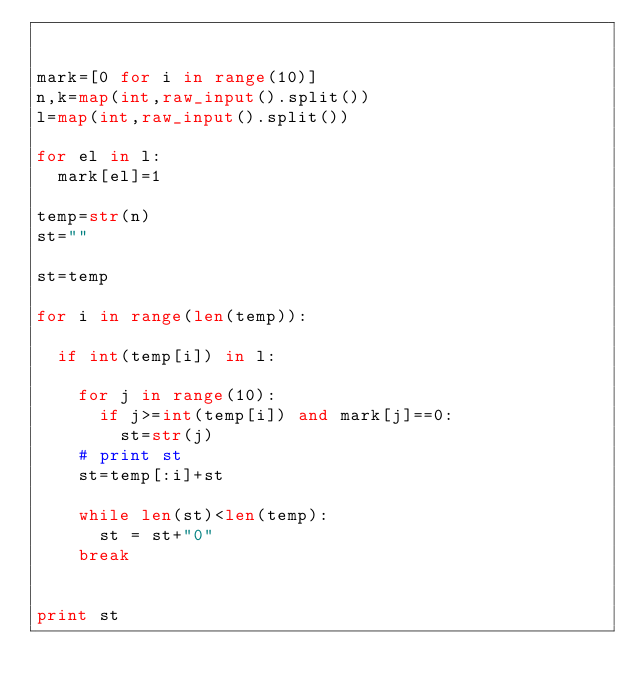<code> <loc_0><loc_0><loc_500><loc_500><_Python_>

mark=[0 for i in range(10)]
n,k=map(int,raw_input().split())
l=map(int,raw_input().split())

for el in l:
	mark[el]=1

temp=str(n)
st=""

st=temp

for i in range(len(temp)):

	if int(temp[i]) in l:
		
		for j in range(10):
			if j>=int(temp[i]) and mark[j]==0:
				st=str(j)
		# print st
		st=temp[:i]+st							

		while len(st)<len(temp):
			st = st+"0"
		break			


print st
</code> 